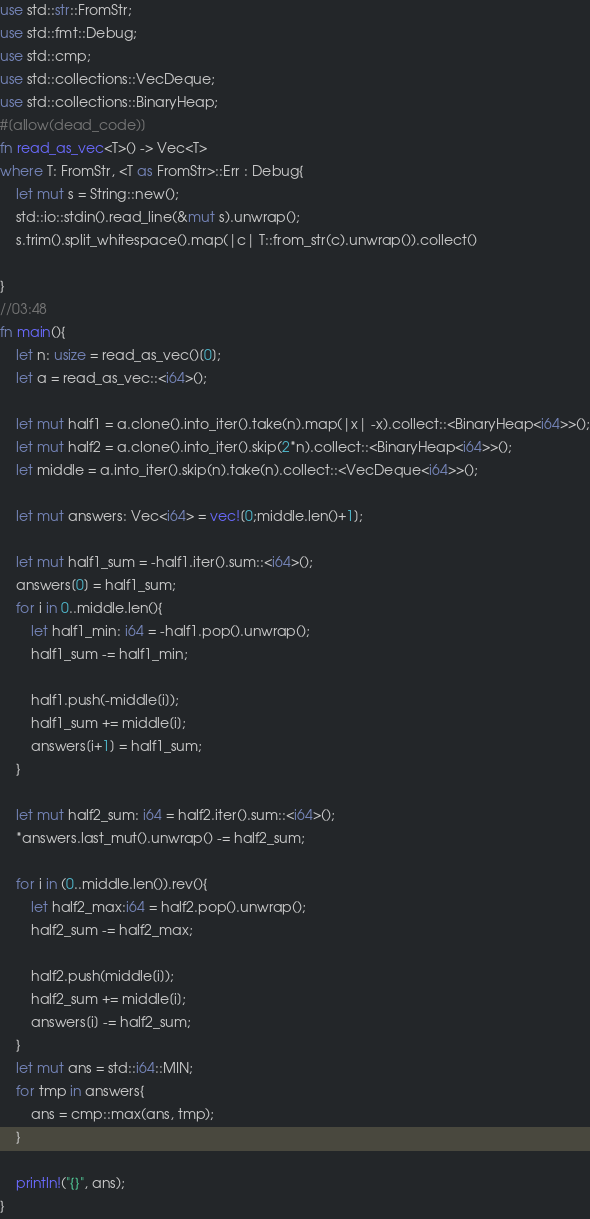<code> <loc_0><loc_0><loc_500><loc_500><_Rust_>use std::str::FromStr;
use std::fmt::Debug;
use std::cmp;
use std::collections::VecDeque;
use std::collections::BinaryHeap;
#[allow(dead_code)]
fn read_as_vec<T>() -> Vec<T>
where T: FromStr, <T as FromStr>::Err : Debug{
    let mut s = String::new();
    std::io::stdin().read_line(&mut s).unwrap();
    s.trim().split_whitespace().map(|c| T::from_str(c).unwrap()).collect()

}
//03:48
fn main(){
    let n: usize = read_as_vec()[0];
    let a = read_as_vec::<i64>();

    let mut half1 = a.clone().into_iter().take(n).map(|x| -x).collect::<BinaryHeap<i64>>();
    let mut half2 = a.clone().into_iter().skip(2*n).collect::<BinaryHeap<i64>>();
    let middle = a.into_iter().skip(n).take(n).collect::<VecDeque<i64>>();

    let mut answers: Vec<i64> = vec![0;middle.len()+1];

    let mut half1_sum = -half1.iter().sum::<i64>();
    answers[0] = half1_sum;
    for i in 0..middle.len(){
        let half1_min: i64 = -half1.pop().unwrap();
        half1_sum -= half1_min;

        half1.push(-middle[i]);
        half1_sum += middle[i];
        answers[i+1] = half1_sum;
    }

    let mut half2_sum: i64 = half2.iter().sum::<i64>();
    *answers.last_mut().unwrap() -= half2_sum;

    for i in (0..middle.len()).rev(){
        let half2_max:i64 = half2.pop().unwrap();
        half2_sum -= half2_max;

        half2.push(middle[i]);
        half2_sum += middle[i];
        answers[i] -= half2_sum;
    }
    let mut ans = std::i64::MIN;
    for tmp in answers{
        ans = cmp::max(ans, tmp);
    }

    println!("{}", ans);
}
</code> 